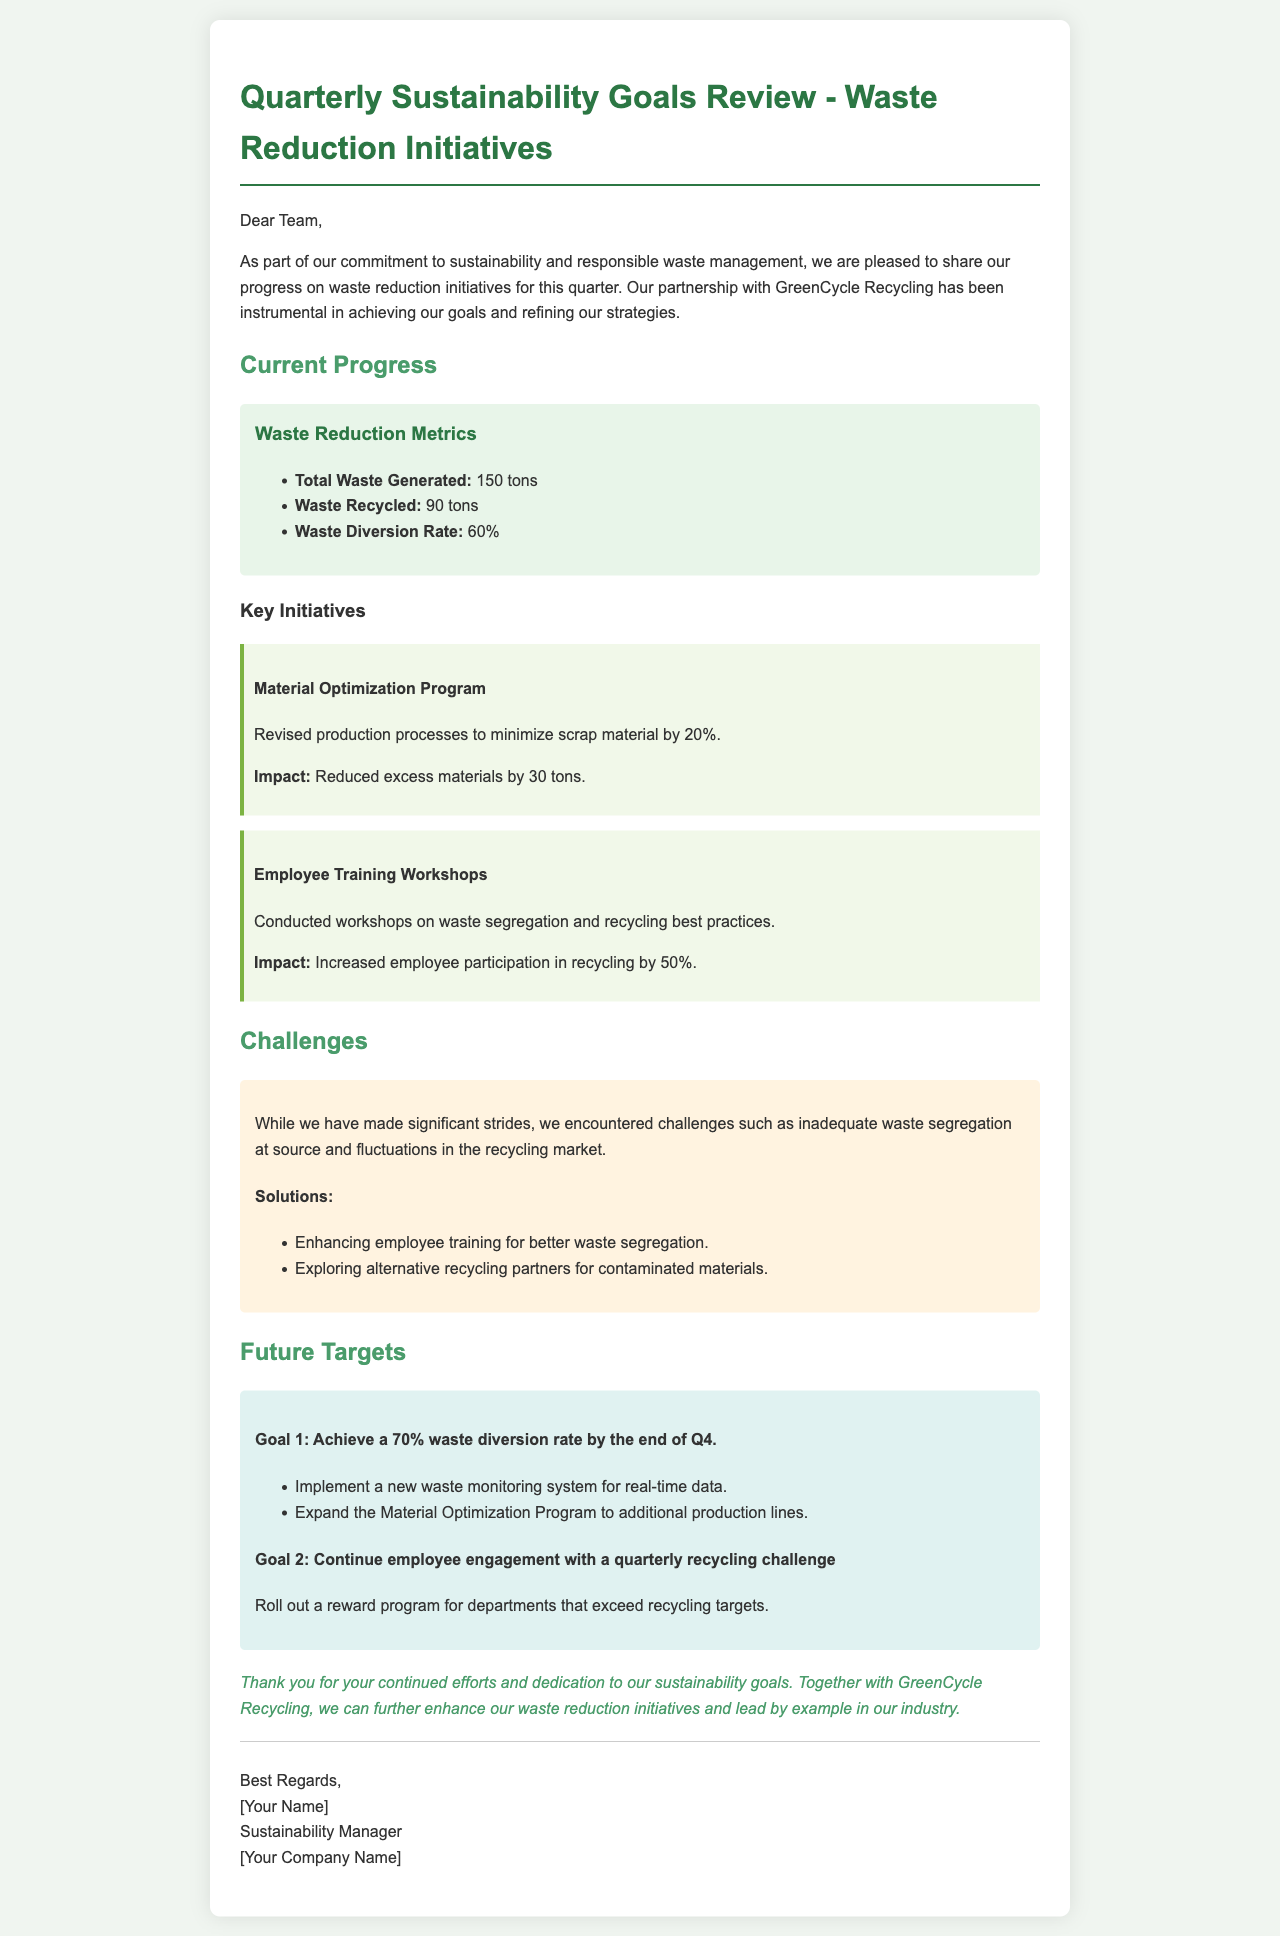What is the total waste generated? The total waste generated is directly specified in the metrics section of the document.
Answer: 150 tons What is the waste diversion rate? The waste diversion rate is listed among the waste reduction metrics in the document.
Answer: 60% Which program focused on reducing scrap material? The document mentions a specific program aimed at optimizing materials to reduce waste.
Answer: Material Optimization Program What percentage increase in recycling participation resulted from employee training? This percentage is noted in the impact statements related to the employee training workshops.
Answer: 50% What is the target waste diversion rate by the end of Q4? The future targets section outlines specific goals, including the diversion rate target.
Answer: 70% What challenge was encountered regarding waste management? The document states some challenges faced in the waste reduction efforts.
Answer: Inadequate waste segregation What is one solution proposed for improving waste segregation? The challenges section includes proposed solutions to the stated issues.
Answer: Enhancing employee training What program will engage employees in recycling? The future targets section describes an initiative for employee participation in recycling activities.
Answer: Quarterly recycling challenge 